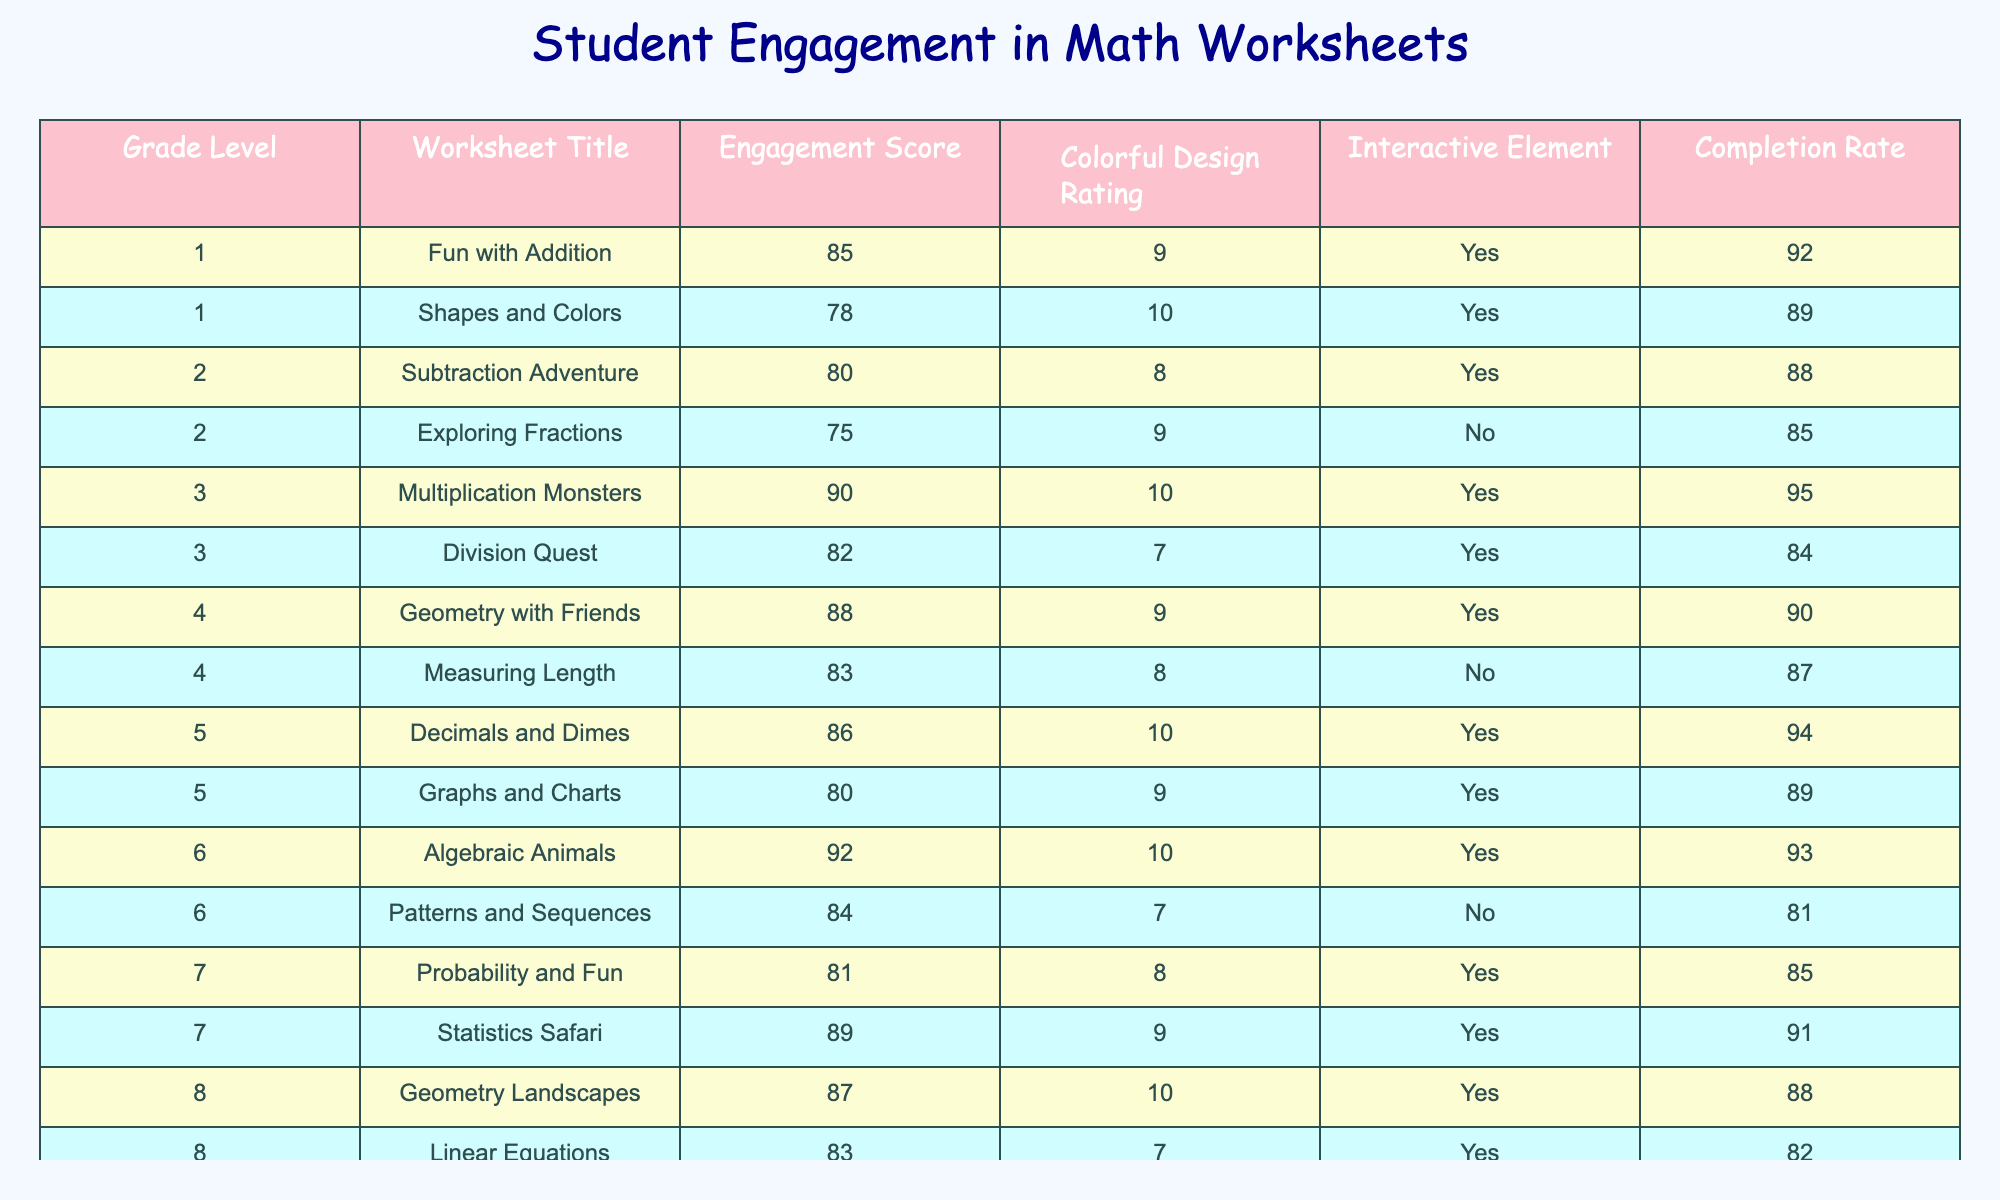What is the highest Engagement Score among the worksheets? The highest Engagement Score can be found by examining the Engagement Score column and identifying the maximum value. From the data, the highest score is 92 from the 'Algebraic Animals' worksheet.
Answer: 92 Which worksheet has the lowest Colorful Design Rating? To find the lowest Colorful Design Rating, we look at the Colorful Design Rating column and find the minimum value. The minimum value is 7, which corresponds to the 'Division Quest' and 'Patterns and Sequences' worksheets.
Answer: 7 How many worksheets have an Interactive Element? We can count the number of worksheets that have 'Yes' in the Interactive Element column. Upon reviewing the table, there are 10 worksheets that include an Interactive Element.
Answer: 10 What is the average Completion Rate for the Grade Level 6 worksheets? To find the average Completion Rate for Grade Level 6, we find the Completion Rates for both worksheets: 93 and 81. The average is (93 + 81) / 2 = 87.
Answer: 87 Is there a worksheet for Grade Level 5 that does not have an Interactive Element? We can check the Grade Level 5 worksheet entries and see if any of them have 'No' for the Interactive Element. Both worksheets for Grade Level 5 ('Decimals and Dimes' and 'Graphs and Charts') have 'Yes', so the answer is No.
Answer: No Which Grade Level has the most worksheets listed? By counting the number of worksheets per grade level, we find that Grade Level 1 has the most entries with 2 worksheets.
Answer: 1 What is the sum of Engagement Scores for all worksheets in Grade Level 4? For Grade Level 4, the Engagement Scores are 88 and 83. Adding these gives us 88 + 83 = 171.
Answer: 171 Which worksheet has the highest Completion Rate and what is that rate? We identify the highest value in the Completion Rate column first. The highest value is 95 from the 'Multiplication Monsters' worksheet.
Answer: 95 What percentage of the worksheets have a Colorful Design Rating of 8 or higher? We count how many worksheets have a Colorful Design Rating of 8 or higher (there are 10 out of 12 total worksheets). The percentage is calculated as (10/12) * 100 = 83.33%.
Answer: 83.33% Which worksheet from Grade Level 3 has a lower Engagement Score than the average for its grade level? The Engagement Scores for Grade Level 3 are 90 and 82, so the average is (90 + 82) / 2 = 86. The worksheet 'Division Quest' has an Engagement Score of 82, which is lower than 86.
Answer: Division Quest 